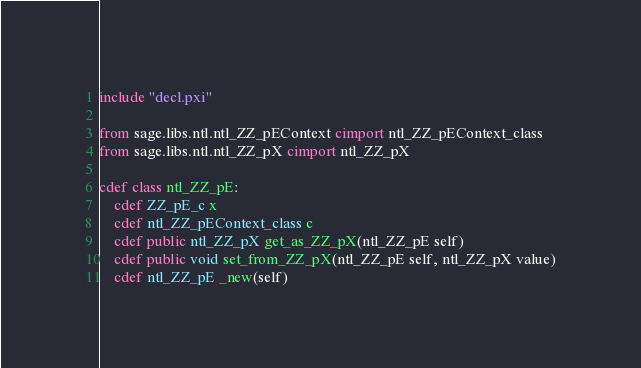<code> <loc_0><loc_0><loc_500><loc_500><_Cython_>
include "decl.pxi"

from sage.libs.ntl.ntl_ZZ_pEContext cimport ntl_ZZ_pEContext_class
from sage.libs.ntl.ntl_ZZ_pX cimport ntl_ZZ_pX

cdef class ntl_ZZ_pE:
    cdef ZZ_pE_c x
    cdef ntl_ZZ_pEContext_class c
    cdef public ntl_ZZ_pX get_as_ZZ_pX(ntl_ZZ_pE self)
    cdef public void set_from_ZZ_pX(ntl_ZZ_pE self, ntl_ZZ_pX value)
    cdef ntl_ZZ_pE _new(self)
</code> 